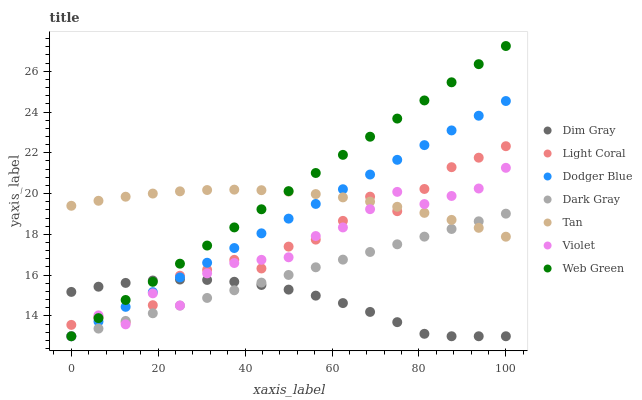Does Dim Gray have the minimum area under the curve?
Answer yes or no. Yes. Does Web Green have the maximum area under the curve?
Answer yes or no. Yes. Does Web Green have the minimum area under the curve?
Answer yes or no. No. Does Dim Gray have the maximum area under the curve?
Answer yes or no. No. Is Dark Gray the smoothest?
Answer yes or no. Yes. Is Violet the roughest?
Answer yes or no. Yes. Is Dim Gray the smoothest?
Answer yes or no. No. Is Dim Gray the roughest?
Answer yes or no. No. Does Dark Gray have the lowest value?
Answer yes or no. Yes. Does Light Coral have the lowest value?
Answer yes or no. No. Does Web Green have the highest value?
Answer yes or no. Yes. Does Dim Gray have the highest value?
Answer yes or no. No. Is Dim Gray less than Tan?
Answer yes or no. Yes. Is Tan greater than Dim Gray?
Answer yes or no. Yes. Does Light Coral intersect Violet?
Answer yes or no. Yes. Is Light Coral less than Violet?
Answer yes or no. No. Is Light Coral greater than Violet?
Answer yes or no. No. Does Dim Gray intersect Tan?
Answer yes or no. No. 